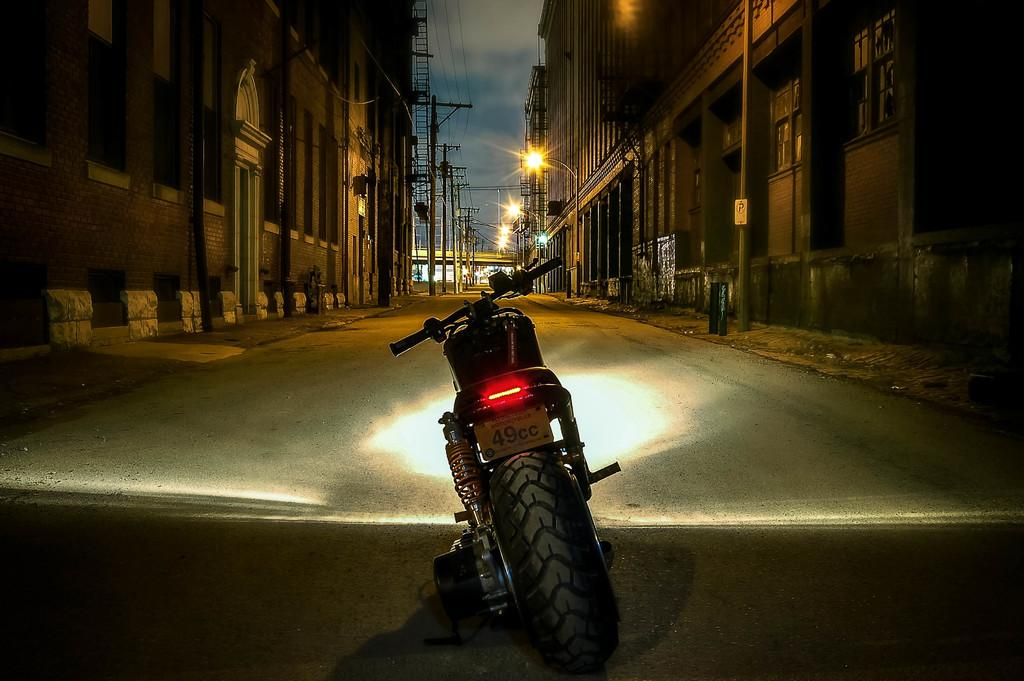What type of vehicle is on the road in the image? There is a motorbike on the road in the image. What structures can be seen in the image? There are buildings visible in the image. What are the poles in the image used for? The poles in the image are likely used for supporting lights or other infrastructure. What type of illumination is present in the image? There are lights in the image. Can you describe any other objects in the image? There are some objects in the image, but their specific nature is not clear from the provided facts. What can be seen in the background of the image? The sky is visible in the background of the image. What type of canvas is being used to paint the motorbike in the image? There is no canvas or painting activity present in the image; it is a photograph of a motorbike on the road. 